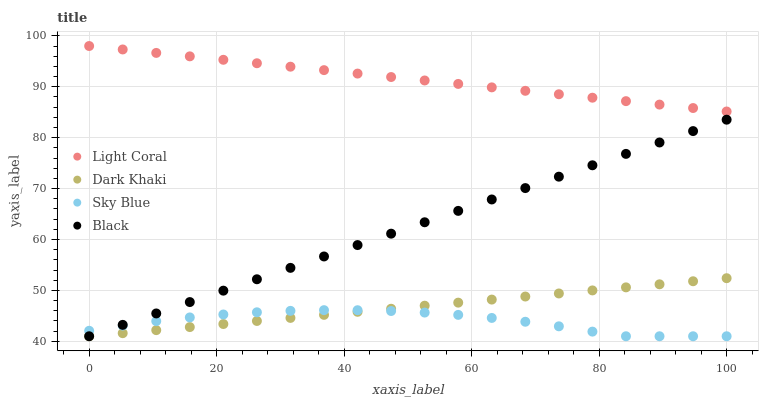Does Sky Blue have the minimum area under the curve?
Answer yes or no. Yes. Does Light Coral have the maximum area under the curve?
Answer yes or no. Yes. Does Dark Khaki have the minimum area under the curve?
Answer yes or no. No. Does Dark Khaki have the maximum area under the curve?
Answer yes or no. No. Is Black the smoothest?
Answer yes or no. Yes. Is Sky Blue the roughest?
Answer yes or no. Yes. Is Dark Khaki the smoothest?
Answer yes or no. No. Is Dark Khaki the roughest?
Answer yes or no. No. Does Dark Khaki have the lowest value?
Answer yes or no. Yes. Does Light Coral have the highest value?
Answer yes or no. Yes. Does Dark Khaki have the highest value?
Answer yes or no. No. Is Black less than Light Coral?
Answer yes or no. Yes. Is Light Coral greater than Black?
Answer yes or no. Yes. Does Dark Khaki intersect Black?
Answer yes or no. Yes. Is Dark Khaki less than Black?
Answer yes or no. No. Is Dark Khaki greater than Black?
Answer yes or no. No. Does Black intersect Light Coral?
Answer yes or no. No. 